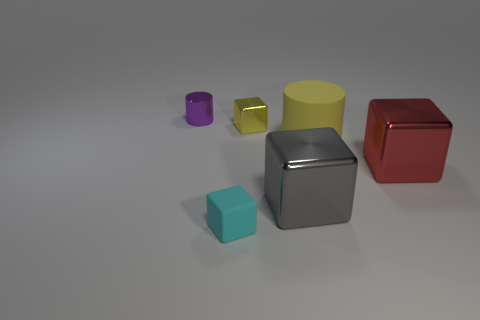What is the size of the purple shiny thing?
Keep it short and to the point. Small. Does the big thing that is right of the large yellow thing have the same material as the gray block?
Offer a very short reply. Yes. How many tiny red cylinders are there?
Provide a succinct answer. 0. How many things are either rubber objects or big gray blocks?
Keep it short and to the point. 3. What number of big rubber cylinders are to the right of the cylinder on the right side of the block that is behind the red thing?
Provide a succinct answer. 0. Is there any other thing that has the same color as the large matte cylinder?
Keep it short and to the point. Yes. There is a large cube that is right of the large yellow cylinder; does it have the same color as the small thing that is to the left of the cyan object?
Provide a succinct answer. No. Is the number of tiny metallic objects on the right side of the yellow rubber object greater than the number of purple cylinders that are in front of the red shiny cube?
Keep it short and to the point. No. What is the material of the big cylinder?
Your response must be concise. Rubber. The tiny shiny thing right of the metal thing behind the tiny shiny thing that is to the right of the tiny cylinder is what shape?
Offer a terse response. Cube. 